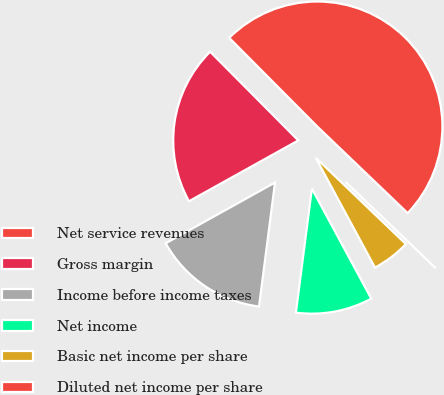<chart> <loc_0><loc_0><loc_500><loc_500><pie_chart><fcel>Net service revenues<fcel>Gross margin<fcel>Income before income taxes<fcel>Net income<fcel>Basic net income per share<fcel>Diluted net income per share<nl><fcel>49.6%<fcel>20.63%<fcel>14.88%<fcel>9.92%<fcel>4.96%<fcel>0.0%<nl></chart> 